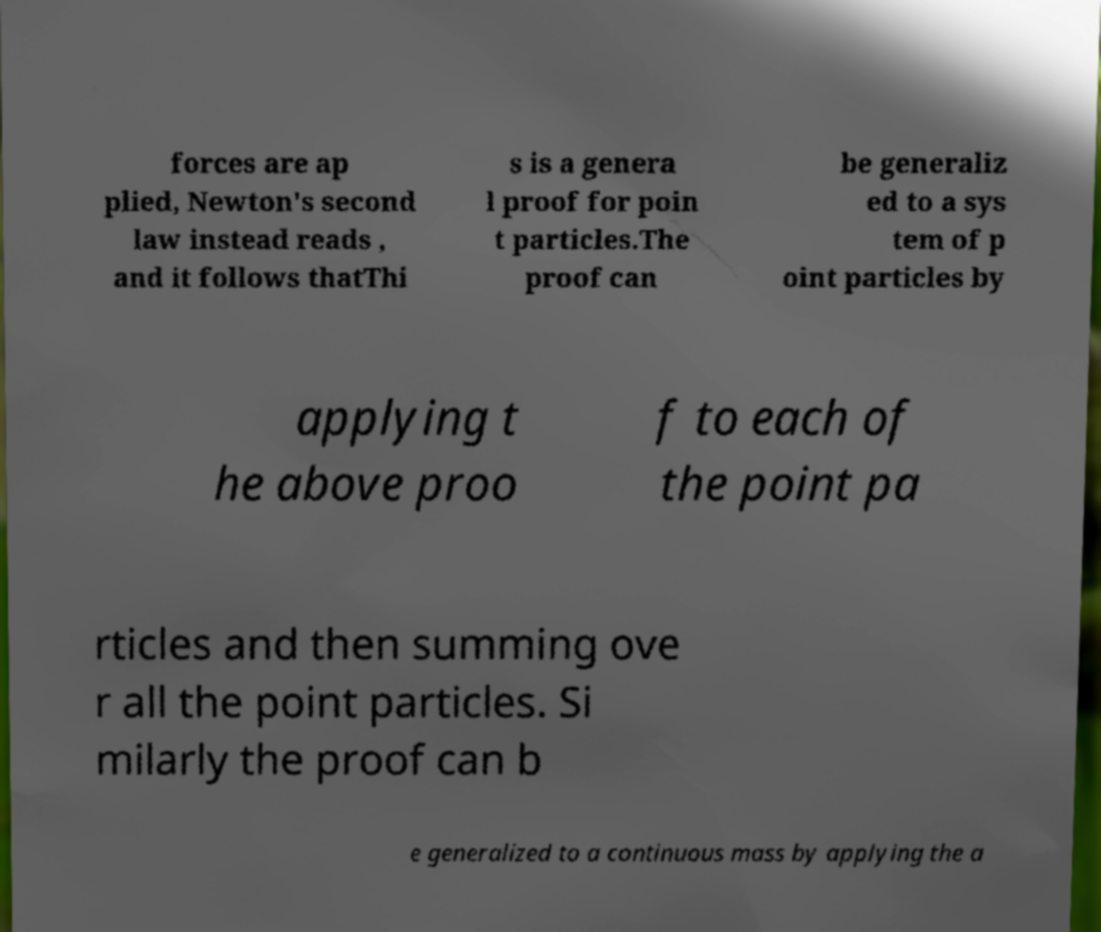For documentation purposes, I need the text within this image transcribed. Could you provide that? forces are ap plied, Newton's second law instead reads , and it follows thatThi s is a genera l proof for poin t particles.The proof can be generaliz ed to a sys tem of p oint particles by applying t he above proo f to each of the point pa rticles and then summing ove r all the point particles. Si milarly the proof can b e generalized to a continuous mass by applying the a 